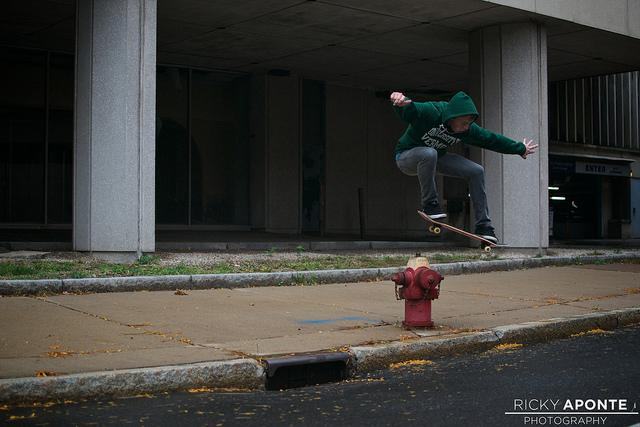Who probably took the picture?

Choices:
A) ricky aponte
B) trump
C) skateboarder
D) steve jobs ricky aponte 